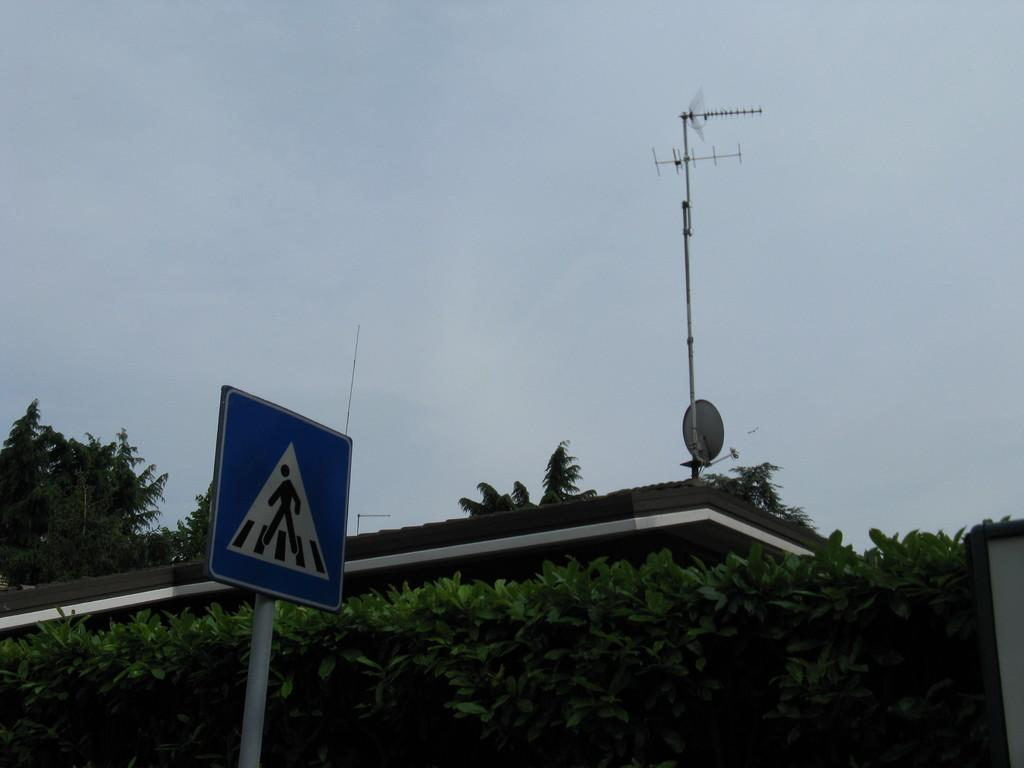What structures can be seen in the image? There are poles and an antenna in the image. What else is present in the image besides the structures? There are signboards and trees in the image. What can be seen in the background of the image? The sky is visible in the background of the image. What type of underwear is hanging on the poles in the image? There is no underwear present in the image; it only features poles, an antenna, signboards, trees, and the sky. How much dust can be seen on the signboards in the image? There is no mention of dust in the image, and the cleanliness of the signboards cannot be determined from the provided facts. 